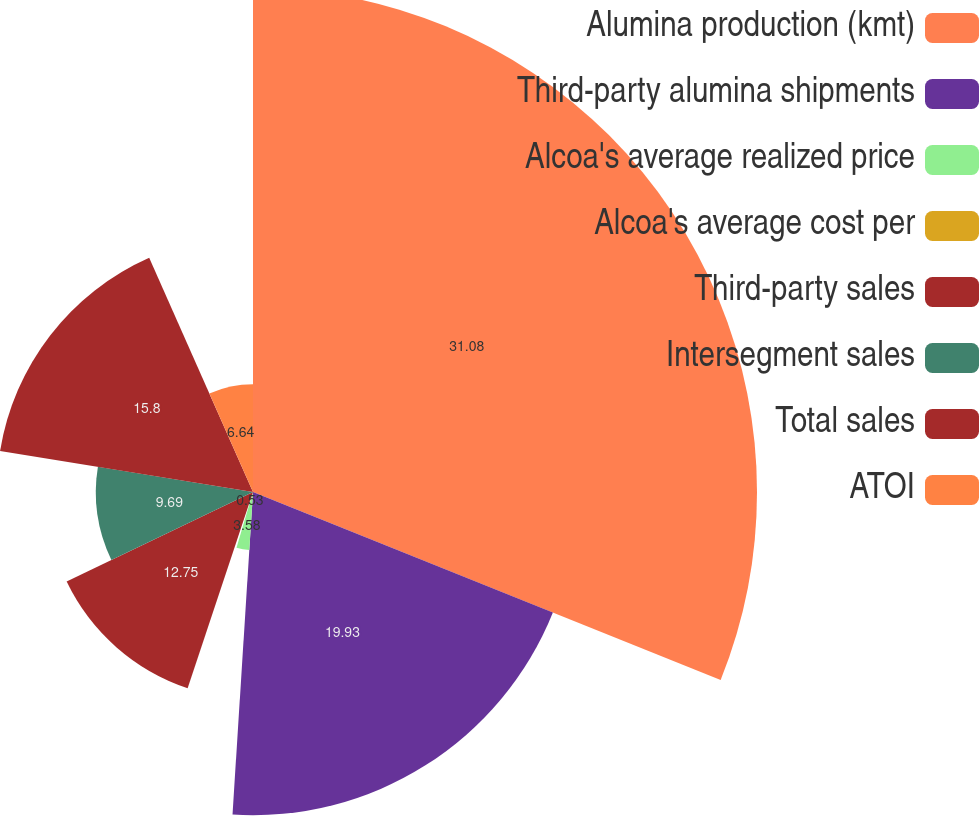Convert chart to OTSL. <chart><loc_0><loc_0><loc_500><loc_500><pie_chart><fcel>Alumina production (kmt)<fcel>Third-party alumina shipments<fcel>Alcoa's average realized price<fcel>Alcoa's average cost per<fcel>Third-party sales<fcel>Intersegment sales<fcel>Total sales<fcel>ATOI<nl><fcel>31.08%<fcel>19.93%<fcel>3.58%<fcel>0.53%<fcel>12.75%<fcel>9.69%<fcel>15.8%<fcel>6.64%<nl></chart> 